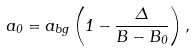<formula> <loc_0><loc_0><loc_500><loc_500>a _ { 0 } = a _ { b g } \left ( 1 - \frac { \Delta } { B - B _ { 0 } } \right ) ,</formula> 